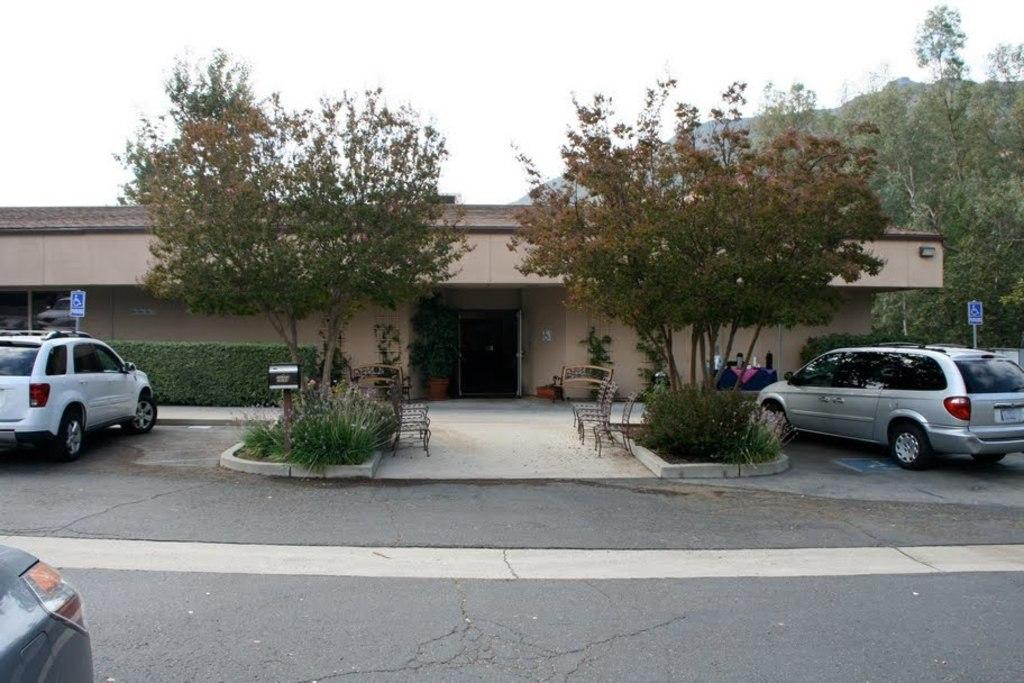What can be seen beside the road in the image? There are vehicles placed side of the road in the image. What is the location of the vehicles in relation to a building? The vehicles are in front of a house in the image. What type of seating is available in the image? There are benches in the image. What type of vegetation is present in the image? Trees are present in the image. What type of sand can be seen blowing in the air in the image? There is no sand or blowing air present in the image. Is there a rifle visible in the image? No, there is no rifle present in the image. 